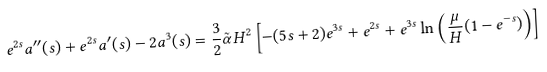<formula> <loc_0><loc_0><loc_500><loc_500>e ^ { 2 s } a ^ { \prime \prime } ( s ) + e ^ { 2 s } a ^ { \prime } ( s ) - 2 a ^ { 3 } ( s ) = \frac { 3 } { 2 } \tilde { \alpha } H ^ { 2 } \left [ - ( 5 s + 2 ) e ^ { 3 s } + e ^ { 2 s } + e ^ { 3 s } \ln \left ( \frac { \mu } { H } ( 1 - e ^ { - s } ) \right ) \right ]</formula> 